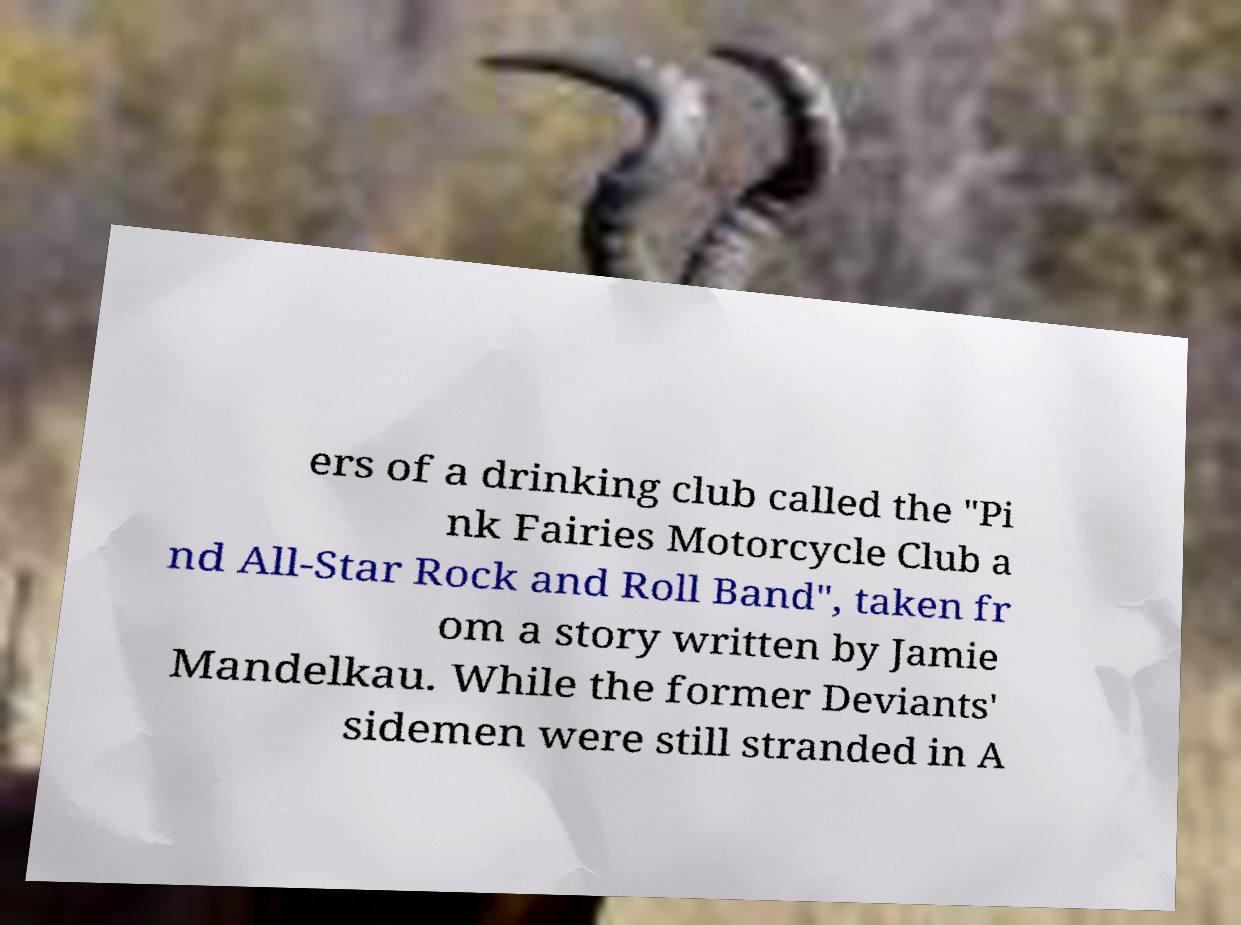Please identify and transcribe the text found in this image. ers of a drinking club called the "Pi nk Fairies Motorcycle Club a nd All-Star Rock and Roll Band", taken fr om a story written by Jamie Mandelkau. While the former Deviants' sidemen were still stranded in A 